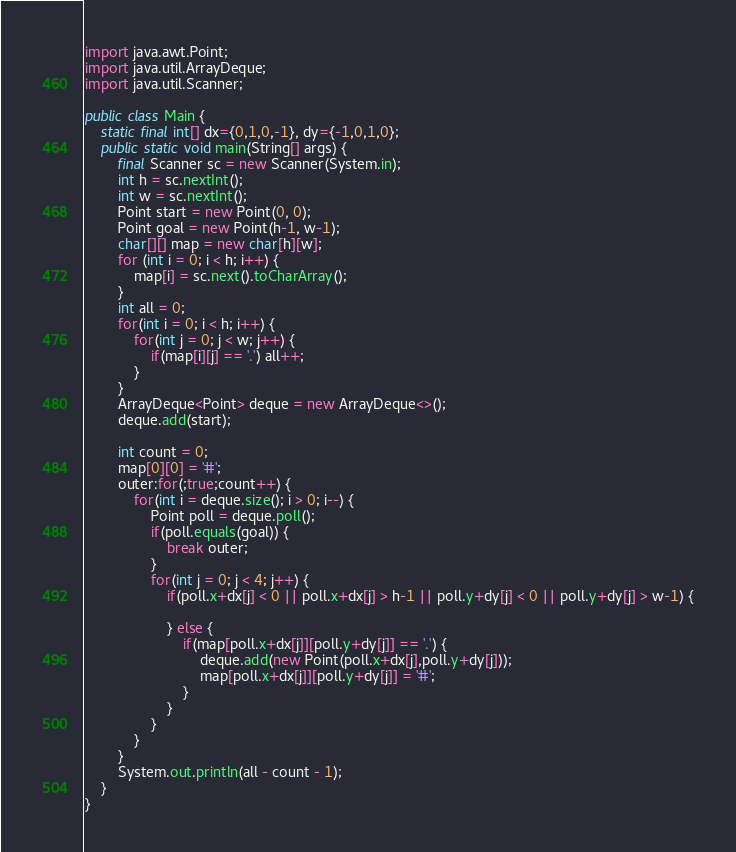<code> <loc_0><loc_0><loc_500><loc_500><_Java_>import java.awt.Point;
import java.util.ArrayDeque;
import java.util.Scanner;

public class Main {
	static final int[] dx={0,1,0,-1}, dy={-1,0,1,0};
	public static void main(String[] args) {
		final Scanner sc = new Scanner(System.in);
		int h = sc.nextInt();
		int w = sc.nextInt();
		Point start = new Point(0, 0);
		Point goal = new Point(h-1, w-1);
		char[][] map = new char[h][w];
		for (int i = 0; i < h; i++) {
			map[i] = sc.next().toCharArray();
		}
		int all = 0;
		for(int i = 0; i < h; i++) {
			for(int j = 0; j < w; j++) {
				if(map[i][j] == '.') all++;
			}
		}
		ArrayDeque<Point> deque = new ArrayDeque<>();
		deque.add(start);

		int count = 0;
		map[0][0] = '#';
		outer:for(;true;count++) {
			for(int i = deque.size(); i > 0; i--) {
				Point poll = deque.poll();
				if(poll.equals(goal)) {
					break outer;
				}
				for(int j = 0; j < 4; j++) {
					if(poll.x+dx[j] < 0 || poll.x+dx[j] > h-1 || poll.y+dy[j] < 0 || poll.y+dy[j] > w-1) {

					} else {
						if(map[poll.x+dx[j]][poll.y+dy[j]] == '.') {
							deque.add(new Point(poll.x+dx[j],poll.y+dy[j]));
							map[poll.x+dx[j]][poll.y+dy[j]] = '#';
						}
					}
				}
			}
		}
		System.out.println(all - count - 1);
	}
}</code> 